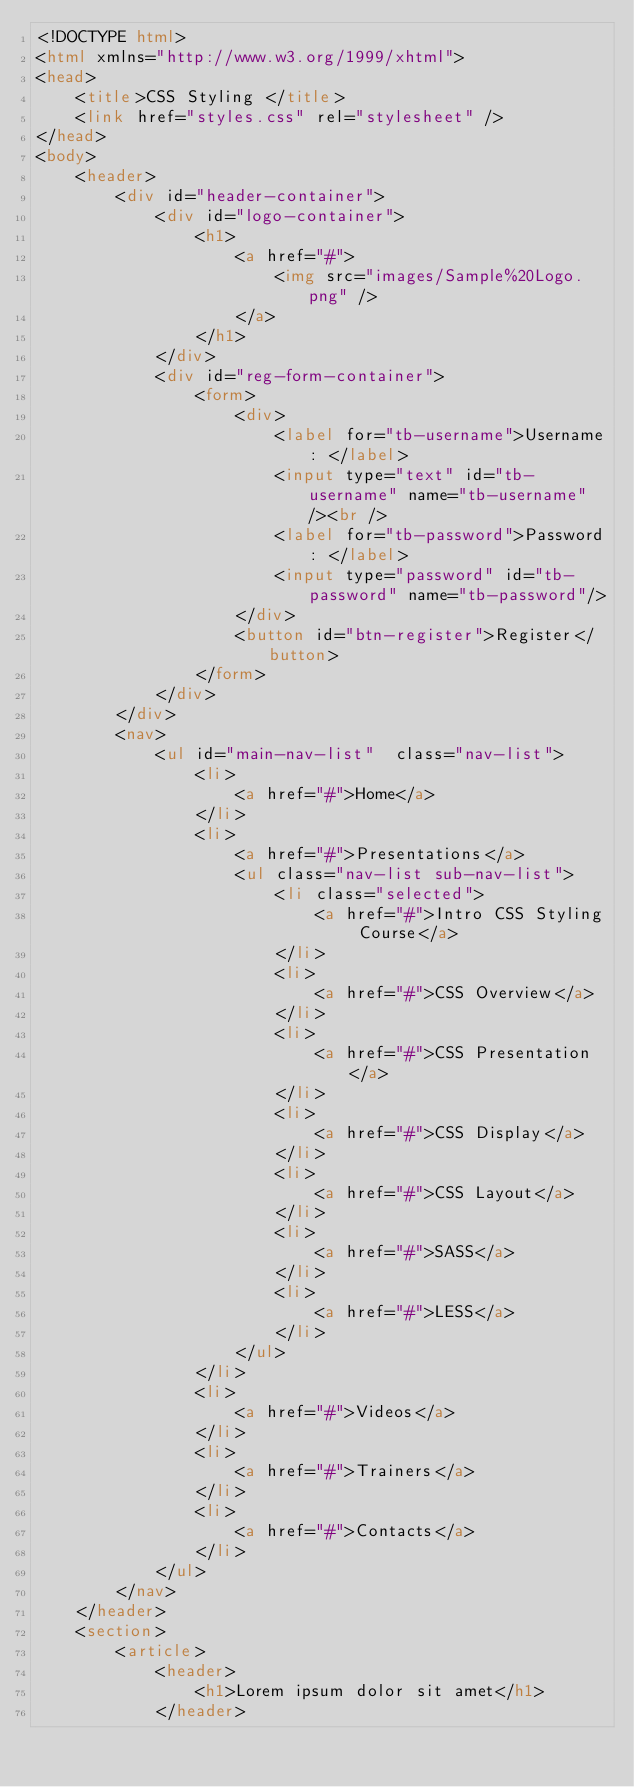<code> <loc_0><loc_0><loc_500><loc_500><_HTML_><!DOCTYPE html>
<html xmlns="http://www.w3.org/1999/xhtml">
<head>
    <title>CSS Styling </title>
    <link href="styles.css" rel="stylesheet" />
</head>
<body>
    <header>
        <div id="header-container">
            <div id="logo-container">
                <h1>
                    <a href="#">
                        <img src="images/Sample%20Logo.png" />
                    </a>
                </h1>
            </div>
            <div id="reg-form-container">
                <form>
                    <div>
                        <label for="tb-username">Username: </label>
                        <input type="text" id="tb-username" name="tb-username"/><br />
                        <label for="tb-password">Password: </label>
                        <input type="password" id="tb-password" name="tb-password"/>
                    </div>
                    <button id="btn-register">Register</button>
                </form>
            </div>
        </div>
        <nav>
            <ul id="main-nav-list"  class="nav-list">
                <li>
                    <a href="#">Home</a>
                </li>
                <li>
                    <a href="#">Presentations</a>
                    <ul class="nav-list sub-nav-list">
                        <li class="selected">
                            <a href="#">Intro CSS Styling Course</a>
                        </li>
                        <li>
                            <a href="#">CSS Overview</a>
                        </li>
                        <li>
                            <a href="#">CSS Presentation</a>
                        </li>
                        <li>
                            <a href="#">CSS Display</a>
                        </li>
                        <li>
                            <a href="#">CSS Layout</a>
                        </li>
                        <li>
                            <a href="#">SASS</a>
                        </li>
                        <li>
                            <a href="#">LESS</a>
                        </li>
                    </ul>
                </li>
                <li>
                    <a href="#">Videos</a>
                </li>
                <li>
                    <a href="#">Trainers</a>
                </li>
                <li>
                    <a href="#">Contacts</a>
                </li>
            </ul>
        </nav>
    </header>
    <section>
        <article>
            <header>
                <h1>Lorem ipsum dolor sit amet</h1>
            </header></code> 